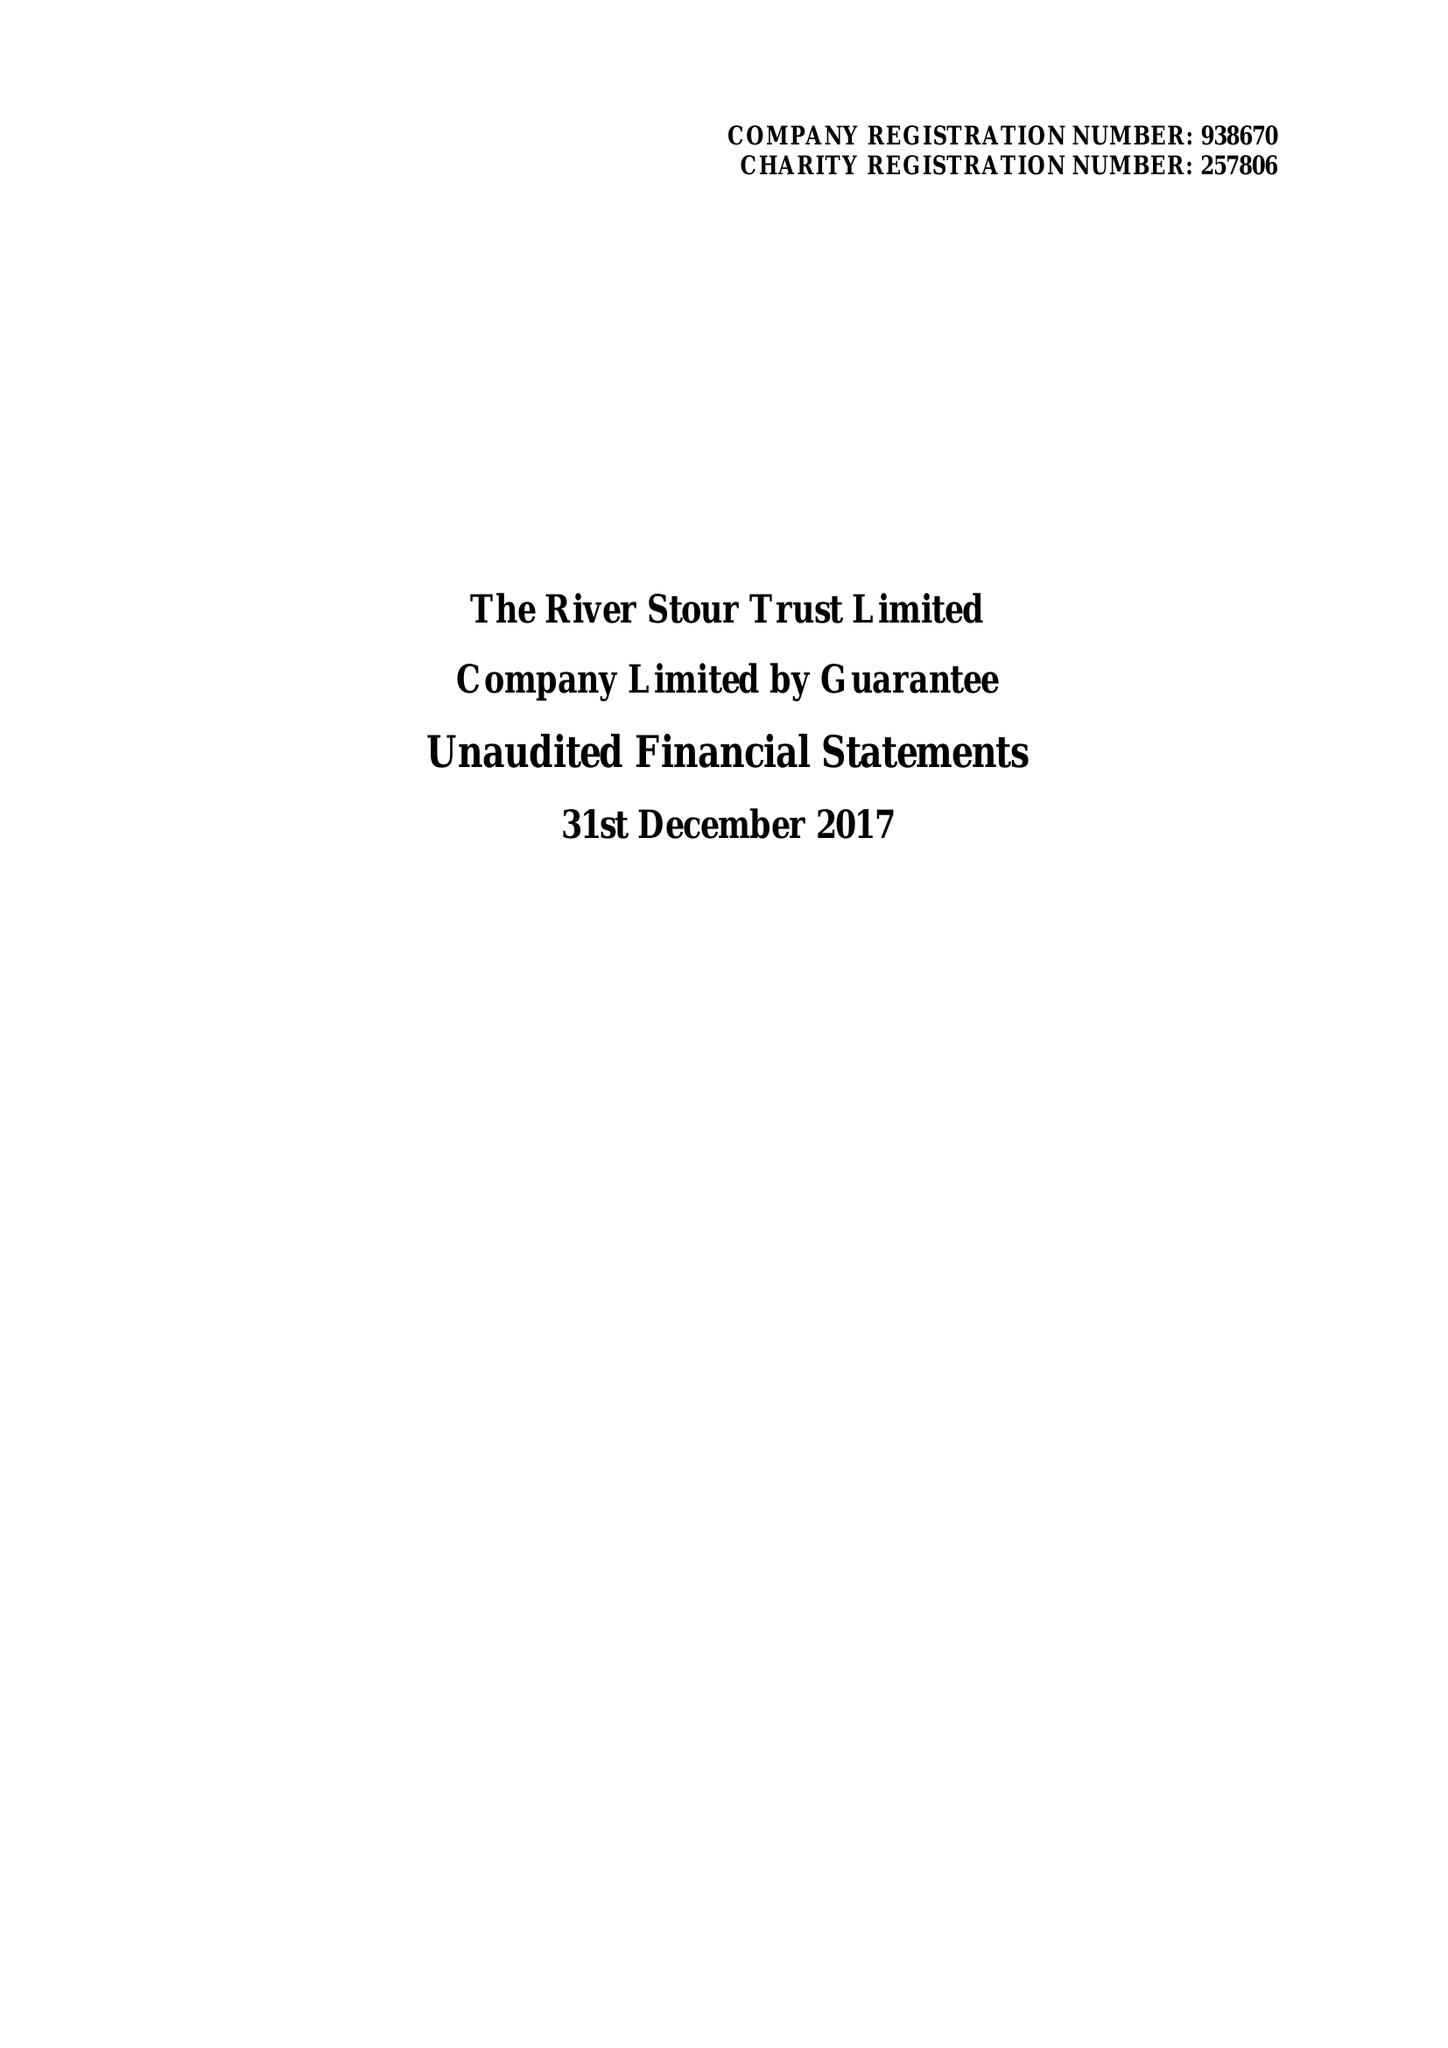What is the value for the address__postcode?
Answer the question using a single word or phrase. CO10 2AN 